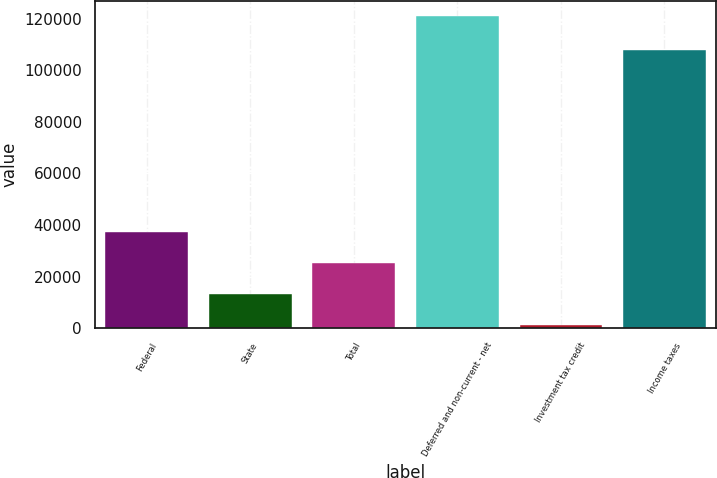<chart> <loc_0><loc_0><loc_500><loc_500><bar_chart><fcel>Federal<fcel>State<fcel>Total<fcel>Deferred and non-current - net<fcel>Investment tax credit<fcel>Income taxes<nl><fcel>37140.8<fcel>13197.6<fcel>25169.2<fcel>120942<fcel>1226<fcel>107773<nl></chart> 